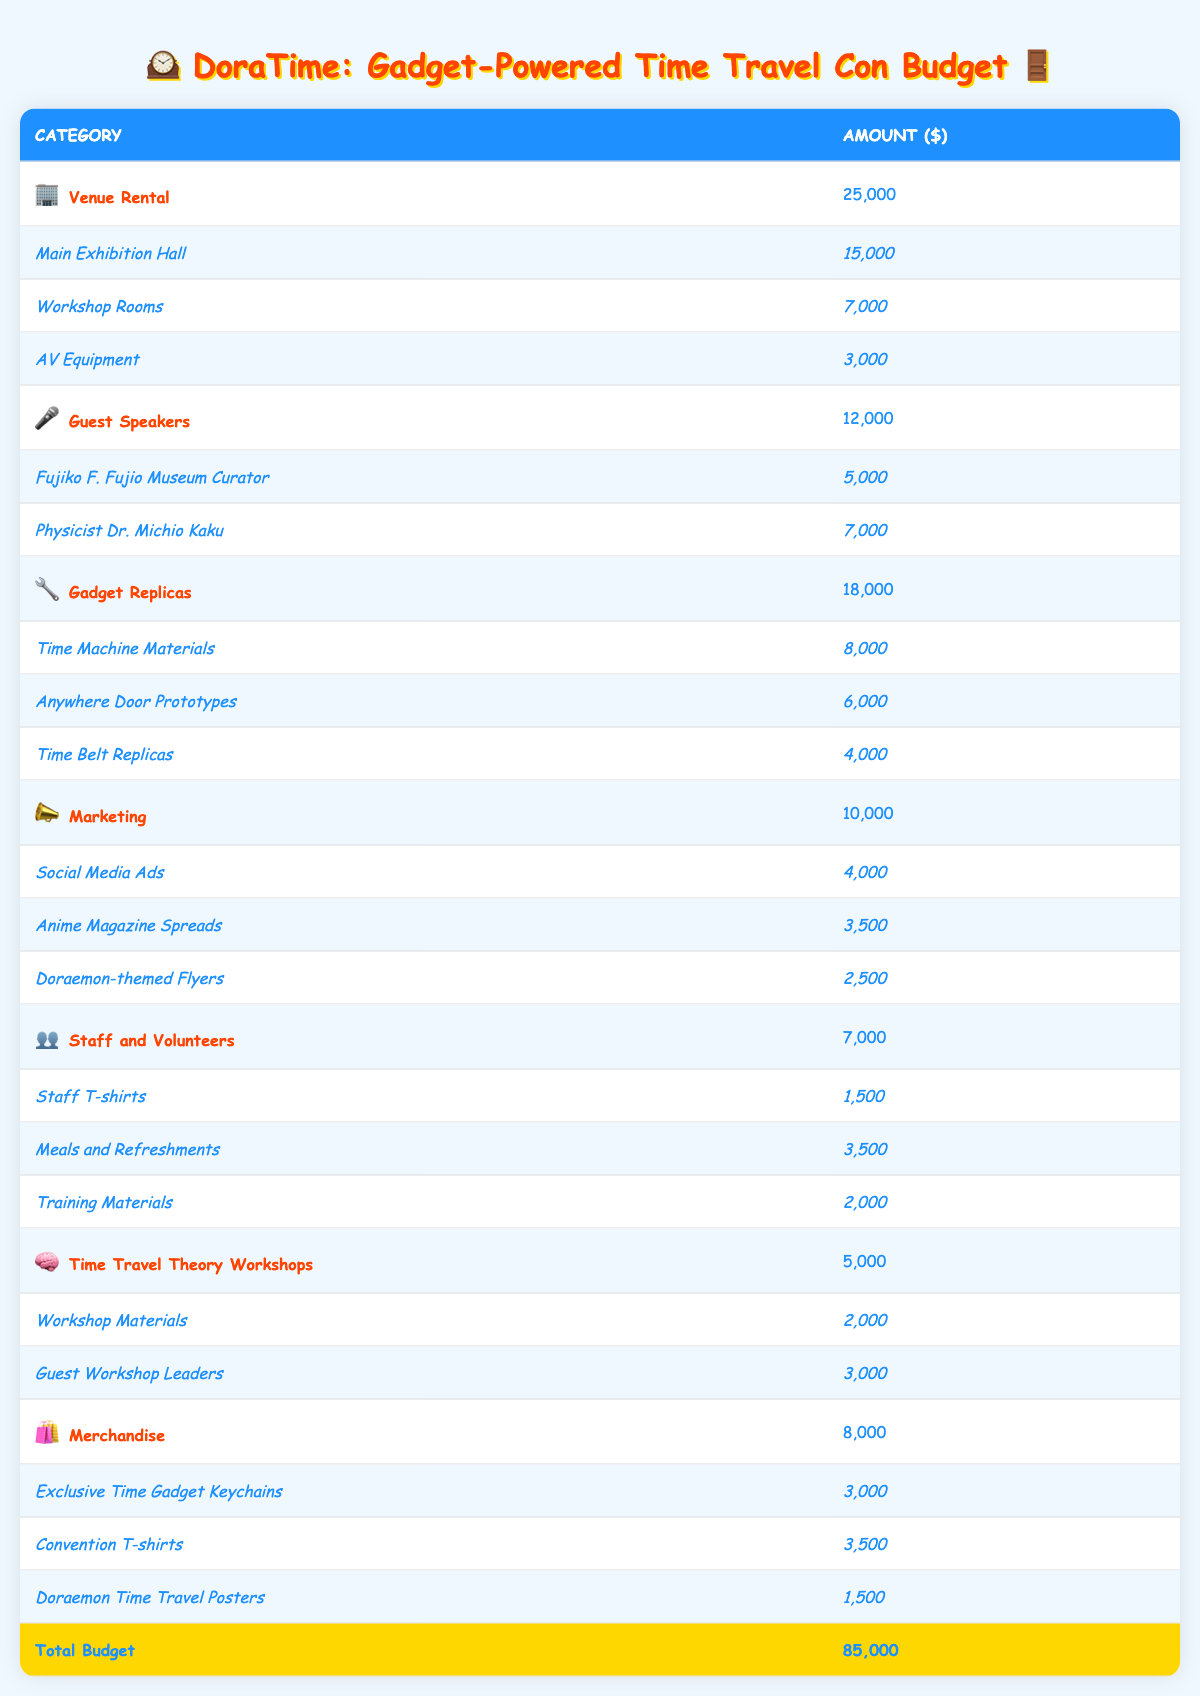What is the total budget allocation for the Venue Rental category? The table shows that the Venue Rental category has an allocated amount of 25,000. This is explicitly stated in the main row for that category.
Answer: 25,000 What is the cost of Meals and Refreshments under Staff and Volunteers? In the Staff and Volunteers category, under the subcategory for Meals and Refreshments, the cost is listed as 3,500. This information is directly available in the table.
Answer: 3,500 Which category has the highest budget allocation and what is that amount? By reviewing the budget categories, Gadget Replicas has the highest allocation with an amount of 18,000. This can be determined by comparing all category amounts in the table.
Answer: 18,000 What is the total expected revenue from Ticket Sales and Merchandise Sales combined? The expected revenue from Ticket Sales is 75,000 and from Merchandise Sales it is 20,000. Adding these amounts gives 75,000 + 20,000 = 95,000.
Answer: 95,000 Is the expected profit greater than 30,000? The expected profit is 25,000, which is less than 30,000. This can be confirmed by comparing the two values from the table.
Answer: No What percentage of the total budget is allocated to Marketing? The Marketing category has a budget of 10,000. To find the percentage, we calculate (10,000 / 85,000) * 100 = 11.76%. Thus, approximately 12%.
Answer: 12% What is the combined cost for Gadget Replicas and Guest Speakers? The Gadget Replicas category costs 18,000, and Guest Speakers costs 12,000. Adding these amounts gives 18,000 + 12,000 = 30,000.
Answer: 30,000 How much more budget is allocated to Venue Rental compared to Time Travel Theory Workshops? The Venue Rental amount is 25,000 and Time Travel Theory Workshops is 5,000. The difference is 25,000 - 5,000 = 20,000.
Answer: 20,000 